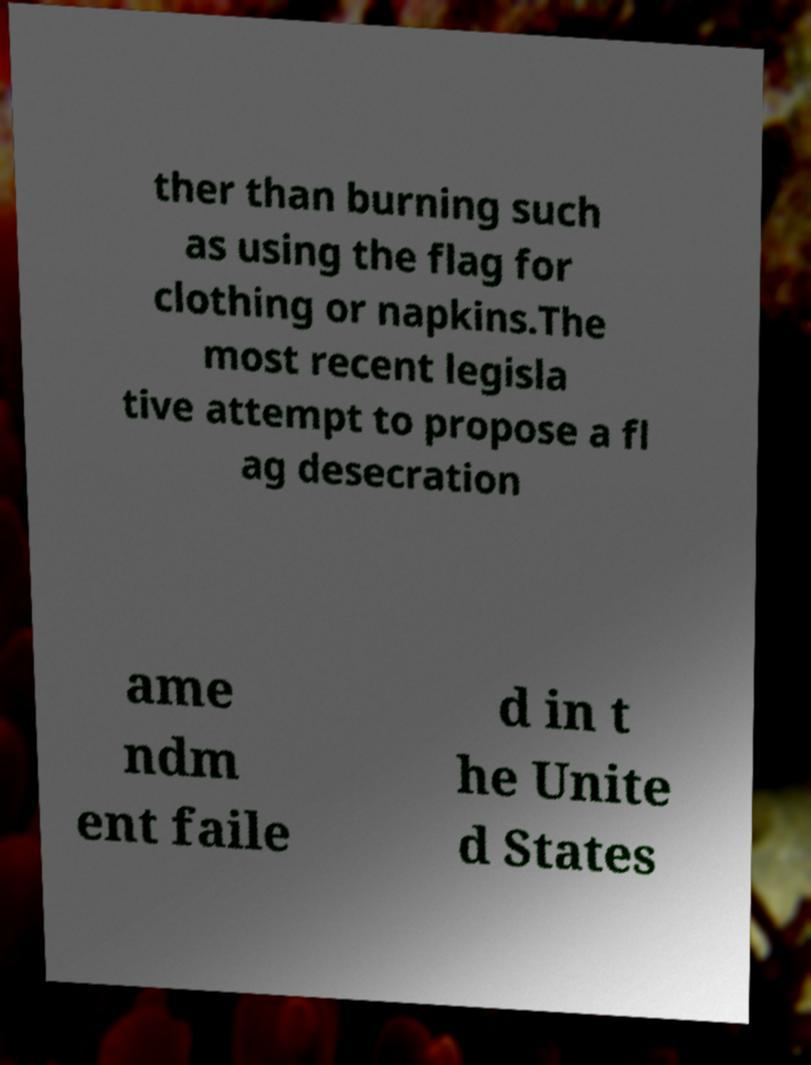I need the written content from this picture converted into text. Can you do that? ther than burning such as using the flag for clothing or napkins.The most recent legisla tive attempt to propose a fl ag desecration ame ndm ent faile d in t he Unite d States 